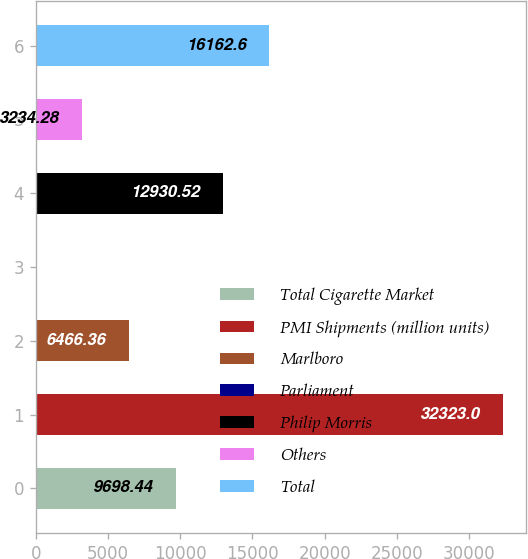Convert chart to OTSL. <chart><loc_0><loc_0><loc_500><loc_500><bar_chart><fcel>Total Cigarette Market<fcel>PMI Shipments (million units)<fcel>Marlboro<fcel>Parliament<fcel>Philip Morris<fcel>Others<fcel>Total<nl><fcel>9698.44<fcel>32323<fcel>6466.36<fcel>2.2<fcel>12930.5<fcel>3234.28<fcel>16162.6<nl></chart> 